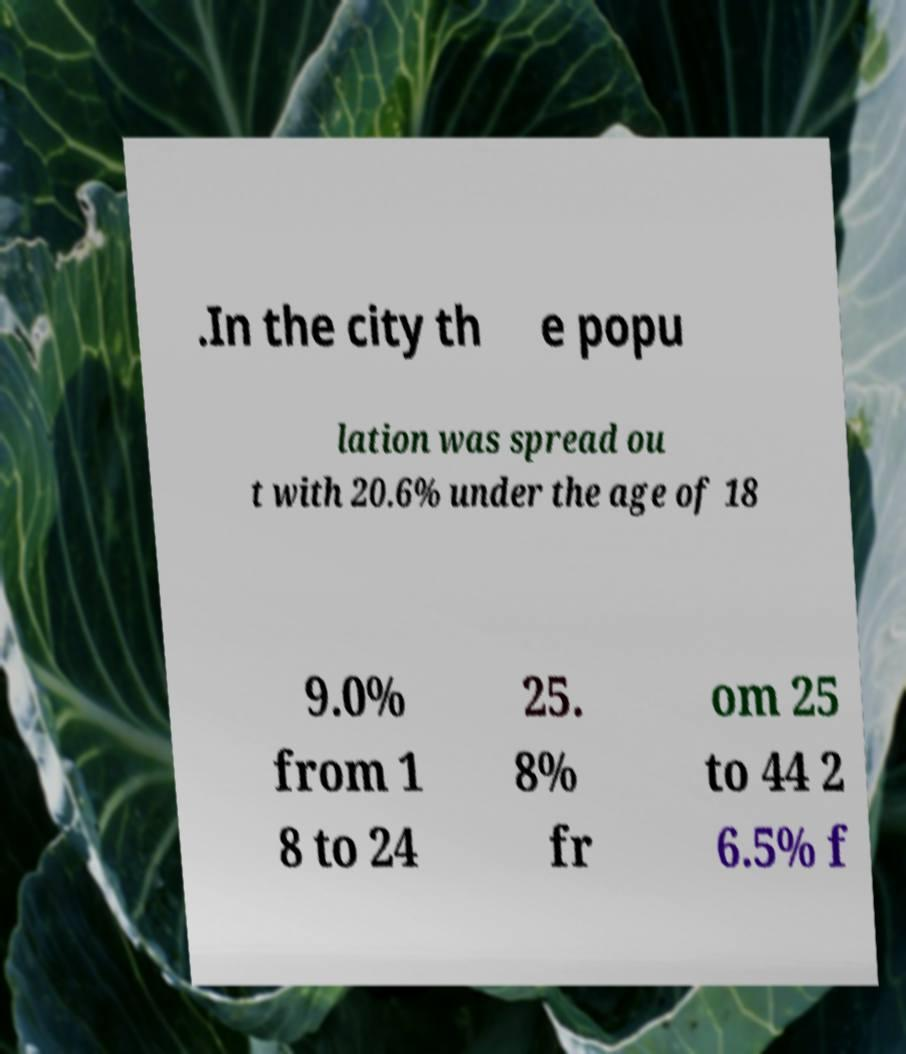There's text embedded in this image that I need extracted. Can you transcribe it verbatim? .In the city th e popu lation was spread ou t with 20.6% under the age of 18 9.0% from 1 8 to 24 25. 8% fr om 25 to 44 2 6.5% f 